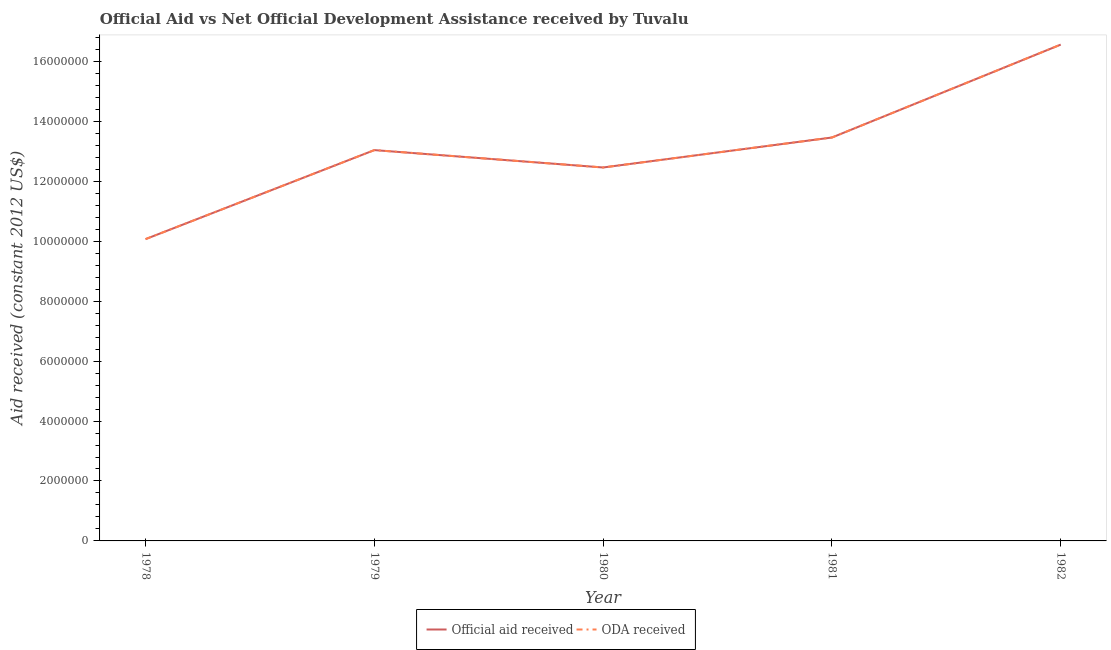Is the number of lines equal to the number of legend labels?
Keep it short and to the point. Yes. What is the oda received in 1981?
Provide a succinct answer. 1.35e+07. Across all years, what is the maximum oda received?
Your answer should be compact. 1.66e+07. Across all years, what is the minimum oda received?
Offer a very short reply. 1.01e+07. In which year was the official aid received maximum?
Ensure brevity in your answer.  1982. In which year was the official aid received minimum?
Provide a short and direct response. 1978. What is the total oda received in the graph?
Give a very brief answer. 6.56e+07. What is the difference between the oda received in 1978 and that in 1981?
Offer a very short reply. -3.39e+06. What is the difference between the official aid received in 1979 and the oda received in 1981?
Provide a succinct answer. -4.20e+05. What is the average oda received per year?
Provide a succinct answer. 1.31e+07. In the year 1981, what is the difference between the oda received and official aid received?
Make the answer very short. 0. What is the ratio of the official aid received in 1980 to that in 1982?
Keep it short and to the point. 0.75. Is the official aid received in 1979 less than that in 1982?
Your answer should be compact. Yes. What is the difference between the highest and the second highest official aid received?
Your response must be concise. 3.10e+06. What is the difference between the highest and the lowest official aid received?
Your answer should be very brief. 6.49e+06. In how many years, is the oda received greater than the average oda received taken over all years?
Offer a terse response. 2. Is the sum of the oda received in 1980 and 1982 greater than the maximum official aid received across all years?
Provide a succinct answer. Yes. How many years are there in the graph?
Your answer should be very brief. 5. Does the graph contain any zero values?
Provide a succinct answer. No. Does the graph contain grids?
Give a very brief answer. No. Where does the legend appear in the graph?
Keep it short and to the point. Bottom center. How many legend labels are there?
Provide a succinct answer. 2. How are the legend labels stacked?
Your answer should be very brief. Horizontal. What is the title of the graph?
Make the answer very short. Official Aid vs Net Official Development Assistance received by Tuvalu . What is the label or title of the X-axis?
Your response must be concise. Year. What is the label or title of the Y-axis?
Provide a short and direct response. Aid received (constant 2012 US$). What is the Aid received (constant 2012 US$) in Official aid received in 1978?
Ensure brevity in your answer.  1.01e+07. What is the Aid received (constant 2012 US$) in ODA received in 1978?
Keep it short and to the point. 1.01e+07. What is the Aid received (constant 2012 US$) in Official aid received in 1979?
Your answer should be compact. 1.30e+07. What is the Aid received (constant 2012 US$) in ODA received in 1979?
Offer a very short reply. 1.30e+07. What is the Aid received (constant 2012 US$) of Official aid received in 1980?
Offer a terse response. 1.25e+07. What is the Aid received (constant 2012 US$) of ODA received in 1980?
Your response must be concise. 1.25e+07. What is the Aid received (constant 2012 US$) in Official aid received in 1981?
Offer a terse response. 1.35e+07. What is the Aid received (constant 2012 US$) of ODA received in 1981?
Give a very brief answer. 1.35e+07. What is the Aid received (constant 2012 US$) in Official aid received in 1982?
Your response must be concise. 1.66e+07. What is the Aid received (constant 2012 US$) in ODA received in 1982?
Your answer should be compact. 1.66e+07. Across all years, what is the maximum Aid received (constant 2012 US$) of Official aid received?
Keep it short and to the point. 1.66e+07. Across all years, what is the maximum Aid received (constant 2012 US$) in ODA received?
Your answer should be very brief. 1.66e+07. Across all years, what is the minimum Aid received (constant 2012 US$) in Official aid received?
Your answer should be compact. 1.01e+07. Across all years, what is the minimum Aid received (constant 2012 US$) in ODA received?
Provide a short and direct response. 1.01e+07. What is the total Aid received (constant 2012 US$) of Official aid received in the graph?
Ensure brevity in your answer.  6.56e+07. What is the total Aid received (constant 2012 US$) of ODA received in the graph?
Keep it short and to the point. 6.56e+07. What is the difference between the Aid received (constant 2012 US$) in Official aid received in 1978 and that in 1979?
Keep it short and to the point. -2.97e+06. What is the difference between the Aid received (constant 2012 US$) of ODA received in 1978 and that in 1979?
Offer a very short reply. -2.97e+06. What is the difference between the Aid received (constant 2012 US$) of Official aid received in 1978 and that in 1980?
Offer a very short reply. -2.39e+06. What is the difference between the Aid received (constant 2012 US$) in ODA received in 1978 and that in 1980?
Your answer should be very brief. -2.39e+06. What is the difference between the Aid received (constant 2012 US$) in Official aid received in 1978 and that in 1981?
Offer a very short reply. -3.39e+06. What is the difference between the Aid received (constant 2012 US$) in ODA received in 1978 and that in 1981?
Your answer should be very brief. -3.39e+06. What is the difference between the Aid received (constant 2012 US$) in Official aid received in 1978 and that in 1982?
Provide a short and direct response. -6.49e+06. What is the difference between the Aid received (constant 2012 US$) of ODA received in 1978 and that in 1982?
Ensure brevity in your answer.  -6.49e+06. What is the difference between the Aid received (constant 2012 US$) in Official aid received in 1979 and that in 1980?
Give a very brief answer. 5.80e+05. What is the difference between the Aid received (constant 2012 US$) in ODA received in 1979 and that in 1980?
Give a very brief answer. 5.80e+05. What is the difference between the Aid received (constant 2012 US$) in Official aid received in 1979 and that in 1981?
Give a very brief answer. -4.20e+05. What is the difference between the Aid received (constant 2012 US$) of ODA received in 1979 and that in 1981?
Provide a succinct answer. -4.20e+05. What is the difference between the Aid received (constant 2012 US$) of Official aid received in 1979 and that in 1982?
Make the answer very short. -3.52e+06. What is the difference between the Aid received (constant 2012 US$) of ODA received in 1979 and that in 1982?
Make the answer very short. -3.52e+06. What is the difference between the Aid received (constant 2012 US$) in ODA received in 1980 and that in 1981?
Keep it short and to the point. -1.00e+06. What is the difference between the Aid received (constant 2012 US$) of Official aid received in 1980 and that in 1982?
Offer a terse response. -4.10e+06. What is the difference between the Aid received (constant 2012 US$) of ODA received in 1980 and that in 1982?
Provide a succinct answer. -4.10e+06. What is the difference between the Aid received (constant 2012 US$) in Official aid received in 1981 and that in 1982?
Ensure brevity in your answer.  -3.10e+06. What is the difference between the Aid received (constant 2012 US$) of ODA received in 1981 and that in 1982?
Provide a succinct answer. -3.10e+06. What is the difference between the Aid received (constant 2012 US$) in Official aid received in 1978 and the Aid received (constant 2012 US$) in ODA received in 1979?
Your answer should be compact. -2.97e+06. What is the difference between the Aid received (constant 2012 US$) of Official aid received in 1978 and the Aid received (constant 2012 US$) of ODA received in 1980?
Provide a short and direct response. -2.39e+06. What is the difference between the Aid received (constant 2012 US$) in Official aid received in 1978 and the Aid received (constant 2012 US$) in ODA received in 1981?
Ensure brevity in your answer.  -3.39e+06. What is the difference between the Aid received (constant 2012 US$) of Official aid received in 1978 and the Aid received (constant 2012 US$) of ODA received in 1982?
Offer a very short reply. -6.49e+06. What is the difference between the Aid received (constant 2012 US$) of Official aid received in 1979 and the Aid received (constant 2012 US$) of ODA received in 1980?
Offer a very short reply. 5.80e+05. What is the difference between the Aid received (constant 2012 US$) of Official aid received in 1979 and the Aid received (constant 2012 US$) of ODA received in 1981?
Your answer should be compact. -4.20e+05. What is the difference between the Aid received (constant 2012 US$) of Official aid received in 1979 and the Aid received (constant 2012 US$) of ODA received in 1982?
Your answer should be compact. -3.52e+06. What is the difference between the Aid received (constant 2012 US$) of Official aid received in 1980 and the Aid received (constant 2012 US$) of ODA received in 1982?
Your answer should be very brief. -4.10e+06. What is the difference between the Aid received (constant 2012 US$) in Official aid received in 1981 and the Aid received (constant 2012 US$) in ODA received in 1982?
Keep it short and to the point. -3.10e+06. What is the average Aid received (constant 2012 US$) of Official aid received per year?
Provide a succinct answer. 1.31e+07. What is the average Aid received (constant 2012 US$) in ODA received per year?
Your answer should be compact. 1.31e+07. In the year 1978, what is the difference between the Aid received (constant 2012 US$) in Official aid received and Aid received (constant 2012 US$) in ODA received?
Offer a terse response. 0. In the year 1979, what is the difference between the Aid received (constant 2012 US$) in Official aid received and Aid received (constant 2012 US$) in ODA received?
Offer a very short reply. 0. In the year 1981, what is the difference between the Aid received (constant 2012 US$) in Official aid received and Aid received (constant 2012 US$) in ODA received?
Make the answer very short. 0. In the year 1982, what is the difference between the Aid received (constant 2012 US$) in Official aid received and Aid received (constant 2012 US$) in ODA received?
Give a very brief answer. 0. What is the ratio of the Aid received (constant 2012 US$) in Official aid received in 1978 to that in 1979?
Give a very brief answer. 0.77. What is the ratio of the Aid received (constant 2012 US$) of ODA received in 1978 to that in 1979?
Ensure brevity in your answer.  0.77. What is the ratio of the Aid received (constant 2012 US$) in Official aid received in 1978 to that in 1980?
Provide a short and direct response. 0.81. What is the ratio of the Aid received (constant 2012 US$) in ODA received in 1978 to that in 1980?
Offer a very short reply. 0.81. What is the ratio of the Aid received (constant 2012 US$) of Official aid received in 1978 to that in 1981?
Provide a short and direct response. 0.75. What is the ratio of the Aid received (constant 2012 US$) in ODA received in 1978 to that in 1981?
Make the answer very short. 0.75. What is the ratio of the Aid received (constant 2012 US$) of Official aid received in 1978 to that in 1982?
Your response must be concise. 0.61. What is the ratio of the Aid received (constant 2012 US$) of ODA received in 1978 to that in 1982?
Provide a succinct answer. 0.61. What is the ratio of the Aid received (constant 2012 US$) in Official aid received in 1979 to that in 1980?
Offer a terse response. 1.05. What is the ratio of the Aid received (constant 2012 US$) in ODA received in 1979 to that in 1980?
Keep it short and to the point. 1.05. What is the ratio of the Aid received (constant 2012 US$) of Official aid received in 1979 to that in 1981?
Provide a short and direct response. 0.97. What is the ratio of the Aid received (constant 2012 US$) in ODA received in 1979 to that in 1981?
Offer a very short reply. 0.97. What is the ratio of the Aid received (constant 2012 US$) in Official aid received in 1979 to that in 1982?
Make the answer very short. 0.79. What is the ratio of the Aid received (constant 2012 US$) in ODA received in 1979 to that in 1982?
Offer a very short reply. 0.79. What is the ratio of the Aid received (constant 2012 US$) in Official aid received in 1980 to that in 1981?
Offer a very short reply. 0.93. What is the ratio of the Aid received (constant 2012 US$) of ODA received in 1980 to that in 1981?
Give a very brief answer. 0.93. What is the ratio of the Aid received (constant 2012 US$) of Official aid received in 1980 to that in 1982?
Provide a short and direct response. 0.75. What is the ratio of the Aid received (constant 2012 US$) of ODA received in 1980 to that in 1982?
Offer a very short reply. 0.75. What is the ratio of the Aid received (constant 2012 US$) in Official aid received in 1981 to that in 1982?
Provide a short and direct response. 0.81. What is the ratio of the Aid received (constant 2012 US$) of ODA received in 1981 to that in 1982?
Ensure brevity in your answer.  0.81. What is the difference between the highest and the second highest Aid received (constant 2012 US$) in Official aid received?
Offer a terse response. 3.10e+06. What is the difference between the highest and the second highest Aid received (constant 2012 US$) of ODA received?
Offer a very short reply. 3.10e+06. What is the difference between the highest and the lowest Aid received (constant 2012 US$) in Official aid received?
Make the answer very short. 6.49e+06. What is the difference between the highest and the lowest Aid received (constant 2012 US$) of ODA received?
Your response must be concise. 6.49e+06. 